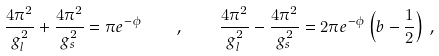<formula> <loc_0><loc_0><loc_500><loc_500>\frac { 4 \pi ^ { 2 } } { g _ { l } ^ { 2 } } + \frac { 4 \pi ^ { 2 } } { g _ { s } ^ { 2 } } = \pi e ^ { - \phi } \quad , \quad \frac { 4 \pi ^ { 2 } } { g _ { l } ^ { 2 } } - \frac { 4 \pi ^ { 2 } } { g _ { s } ^ { 2 } } = 2 \pi e ^ { - \phi } \left ( b - \frac { 1 } { 2 } \right ) \, ,</formula> 